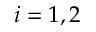<formula> <loc_0><loc_0><loc_500><loc_500>i = 1 , 2</formula> 